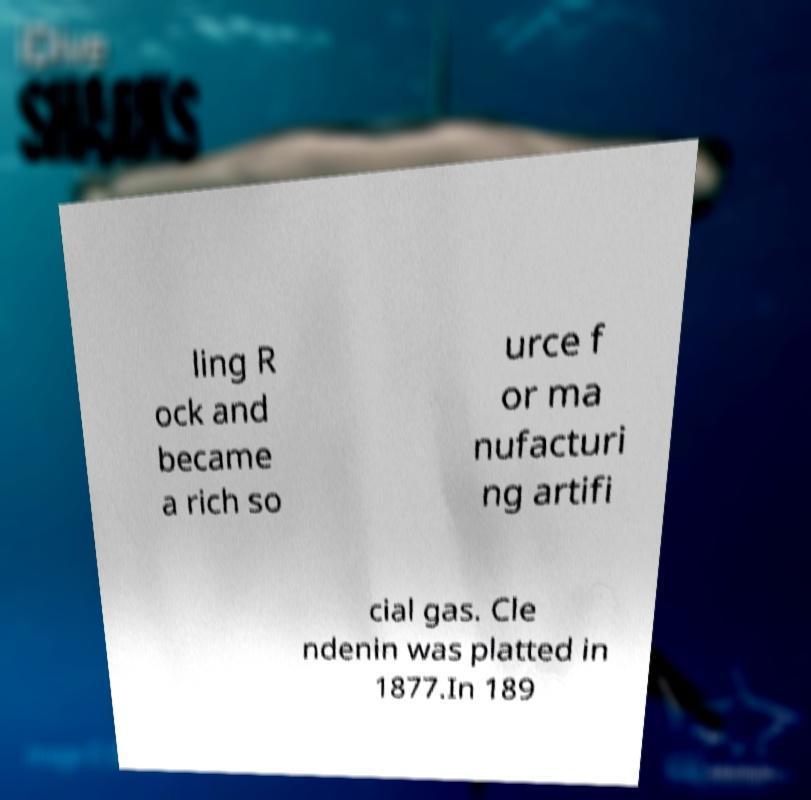Please identify and transcribe the text found in this image. ling R ock and became a rich so urce f or ma nufacturi ng artifi cial gas. Cle ndenin was platted in 1877.In 189 